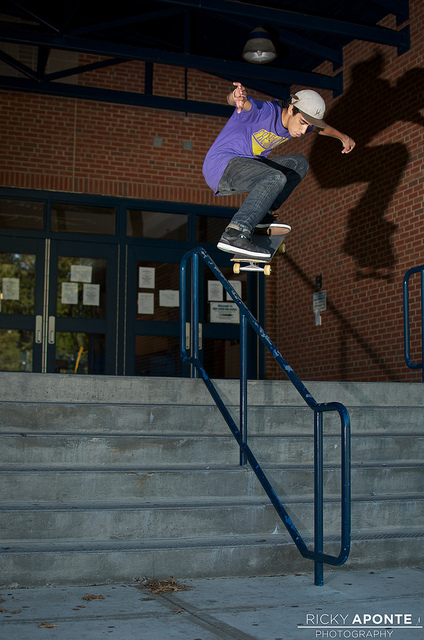<image>What does the boy's shirt say? It is ambiguous what the boy's shirt says as it can be 'team logo', 'skate', 'quicksilver' or 'nothing'. What website is shown? There is no website shown in the image. Nonetheless, it could possibly be 'ricky aponte photography'. What does the boy's shirt say? I don't know what the boy's shirt says. It could be any of the mentioned options. What website is shown? I don't know what website is shown. It can be either 'ricky aponte' or 'ricky aponte photography'. 